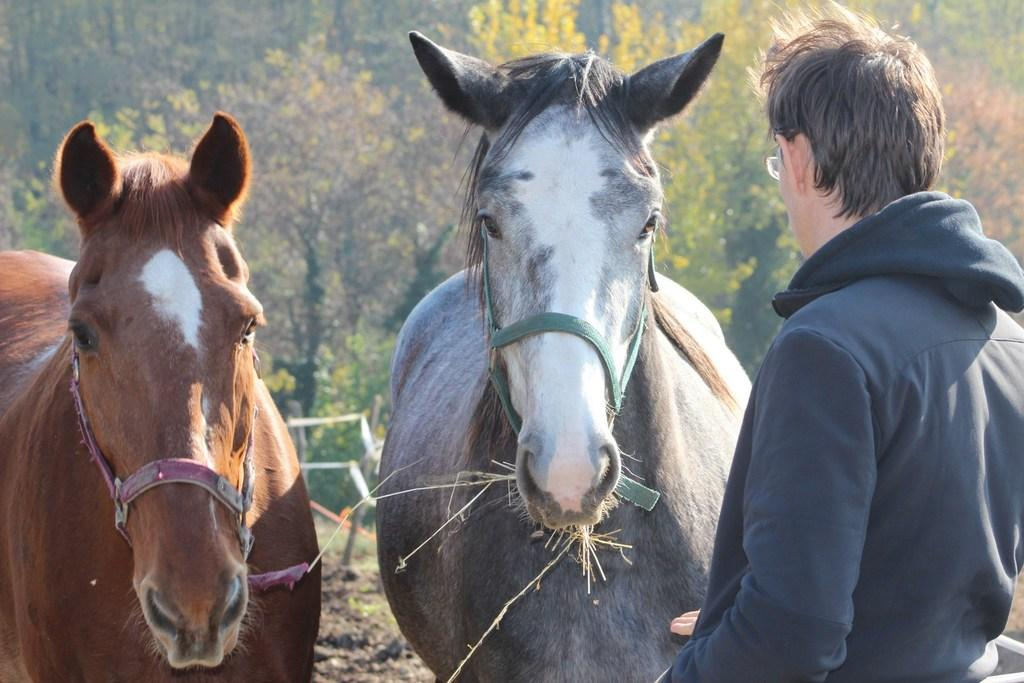How many horses are in the image? There are two horses in the image. What else can be seen on the right side of the image? There is a man on the right side of the image. What type of natural scenery is visible in the background of the image? There are trees in the background of the image. What type of cable can be seen connecting the horses in the image? There is no cable connecting the horses in the image; they are standing independently. 